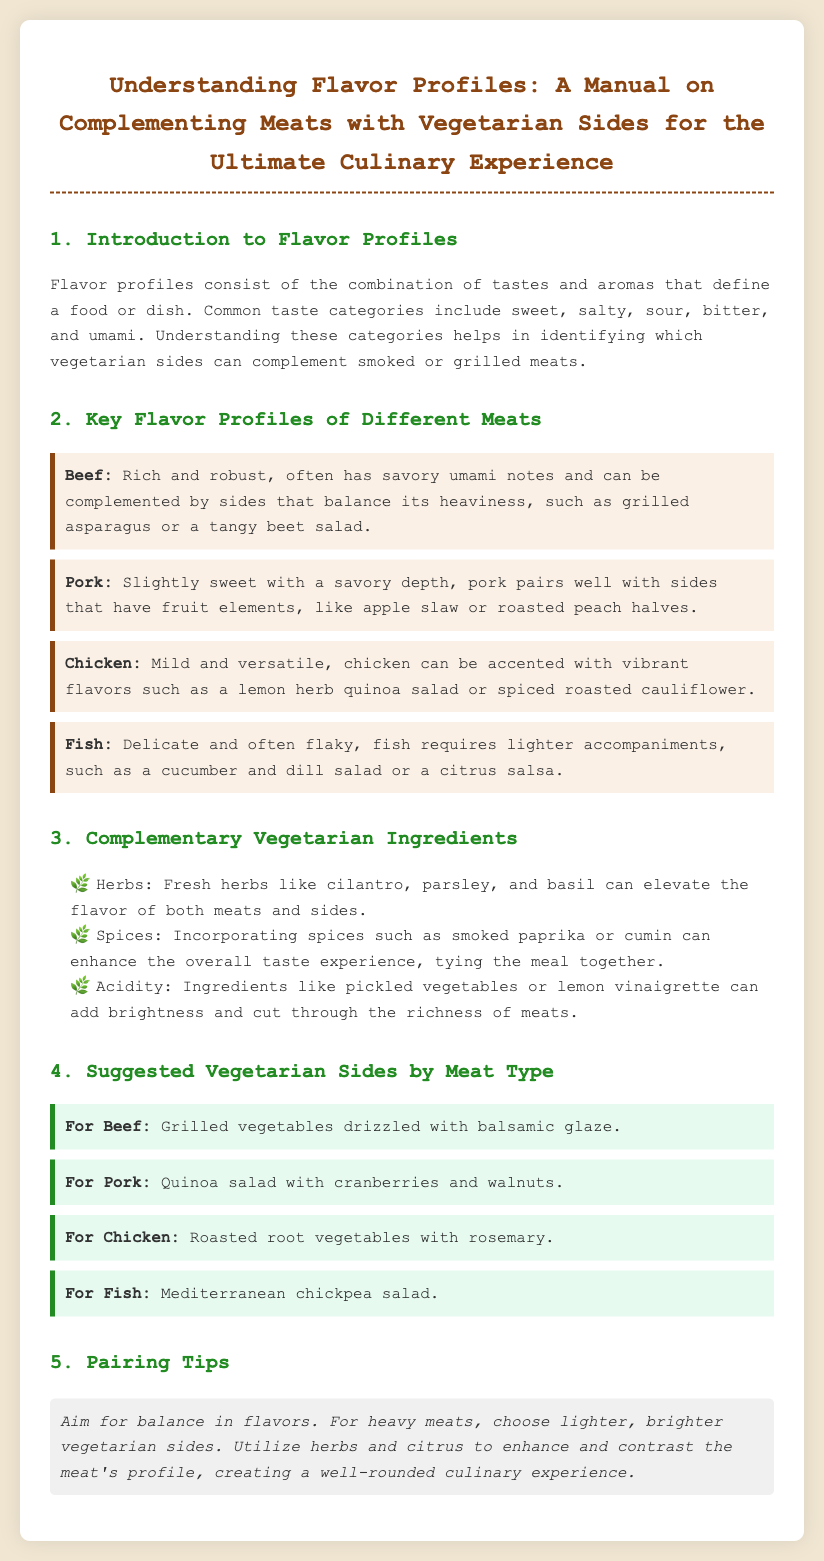What are flavor profiles? Flavor profiles consist of the combination of tastes and aromas that define a food or dish.
Answer: Combination of tastes and aromas What is a suggested side for Chicken? The document states that roasted root vegetables with rosemary is a suggested side for chicken.
Answer: Roasted root vegetables with rosemary What flavor notes are associated with Pork? The text mentions that pork is slightly sweet with a savory depth.
Answer: Slightly sweet with a savory depth Which herbs can elevate flavor? Fresh herbs such as cilantro, parsley, and basil are mentioned as elevating flavors.
Answer: Cilantro, parsley, and basil What is a pairing tip mentioned in the document? The pairing tip suggests aiming for balance in flavors for a well-rounded culinary experience.
Answer: Aim for balance in flavors 